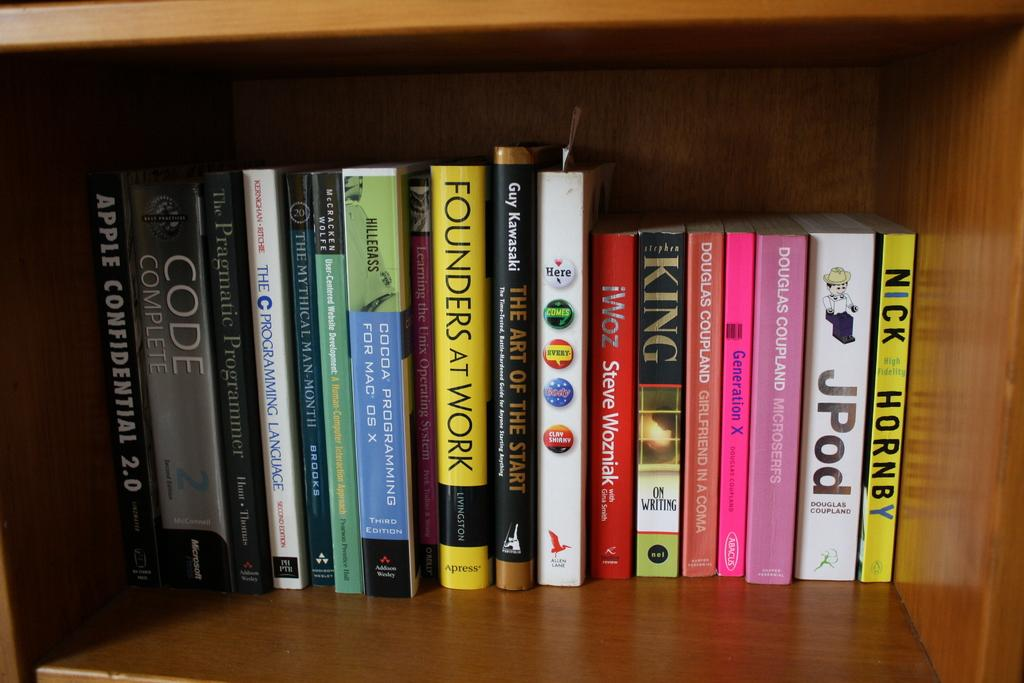<image>
Give a short and clear explanation of the subsequent image. A bunch of books on a bookshelf that includes JPod and Founders At Work. 